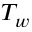<formula> <loc_0><loc_0><loc_500><loc_500>T _ { w }</formula> 